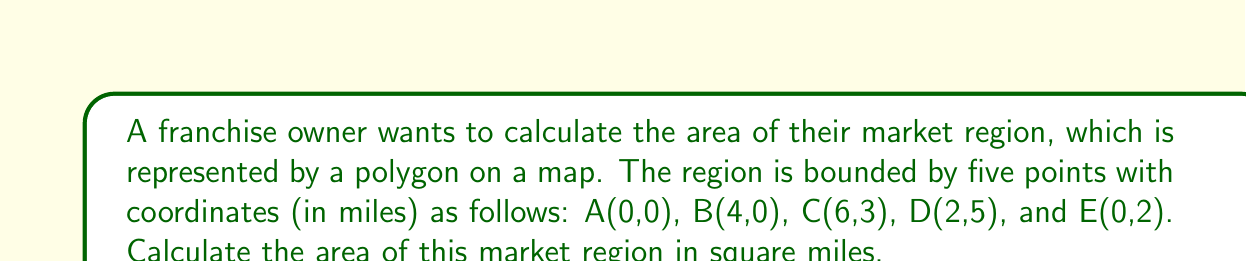Provide a solution to this math problem. To calculate the area of this irregular polygon, we can use the Shoelace formula (also known as the surveyor's formula). The steps are as follows:

1) First, let's arrange the coordinates in order, including the first point at the end to close the polygon:
   (0,0), (4,0), (6,3), (2,5), (0,2), (0,0)

2) The Shoelace formula is:

   $$A = \frac{1}{2}|(x_1y_2 + x_2y_3 + ... + x_ny_1) - (y_1x_2 + y_2x_3 + ... + y_nx_1)|$$

3) Let's apply this formula to our coordinates:

   $$A = \frac{1}{2}|[(0 \cdot 0) + (4 \cdot 3) + (6 \cdot 5) + (2 \cdot 2) + (0 \cdot 0)]$$
   $$- [(0 \cdot 4) + (0 \cdot 6) + (3 \cdot 2) + (5 \cdot 0) + (2 \cdot 0)]|$$

4) Simplify:

   $$A = \frac{1}{2}|[0 + 12 + 30 + 4 + 0] - [0 + 0 + 6 + 0 + 0]|$$
   $$A = \frac{1}{2}|46 - 6|$$
   $$A = \frac{1}{2}|40|$$
   $$A = \frac{1}{2}(40)$$
   $$A = 20$$

5) Therefore, the area of the market region is 20 square miles.

[asy]
unitsize(20);
draw((0,0)--(4,0)--(6,3)--(2,5)--(0,2)--cycle);
label("A(0,0)", (0,0), SW);
label("B(4,0)", (4,0), SE);
label("C(6,3)", (6,3), E);
label("D(2,5)", (2,5), N);
label("E(0,2)", (0,2), W);
[/asy]
Answer: 20 square miles 